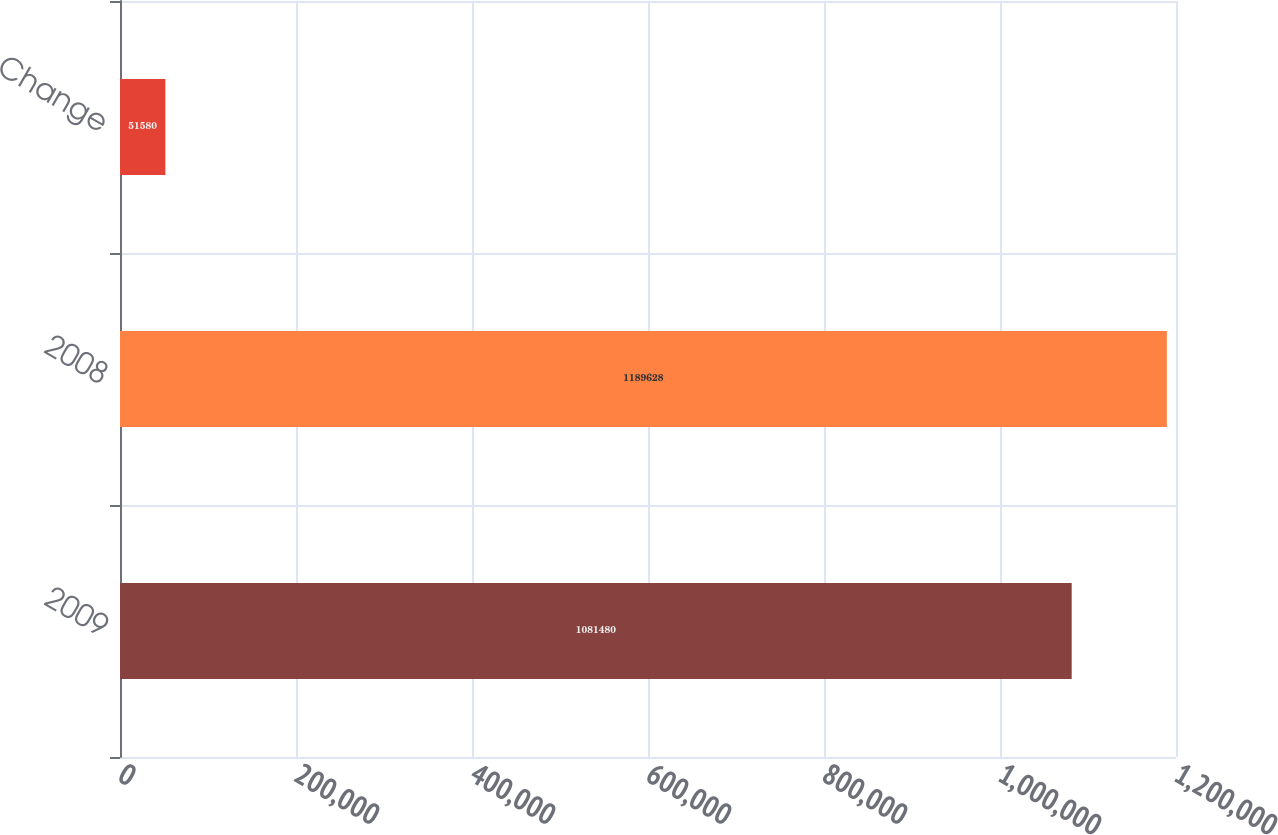Convert chart to OTSL. <chart><loc_0><loc_0><loc_500><loc_500><bar_chart><fcel>2009<fcel>2008<fcel>Change<nl><fcel>1.08148e+06<fcel>1.18963e+06<fcel>51580<nl></chart> 